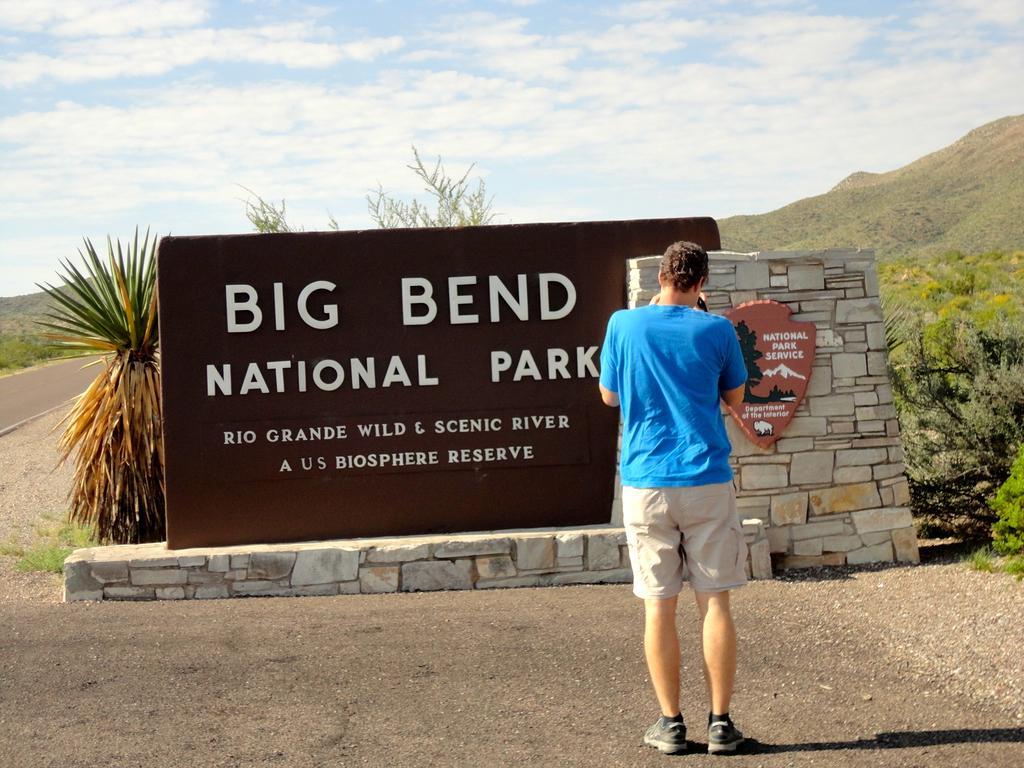Could you give a brief overview of what you see in this image? There is one man standing and wearing a blue color t shirt at the bottom of this image. We can see the text on the wall in the middle of this image. We can see trees behind this wall. The sky is at the top of this image. 